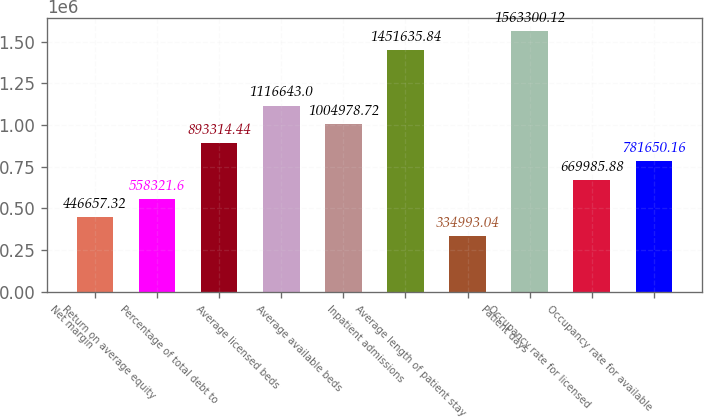Convert chart. <chart><loc_0><loc_0><loc_500><loc_500><bar_chart><fcel>Net margin<fcel>Return on average equity<fcel>Percentage of total debt to<fcel>Average licensed beds<fcel>Average available beds<fcel>Inpatient admissions<fcel>Average length of patient stay<fcel>Patient days<fcel>Occupancy rate for licensed<fcel>Occupancy rate for available<nl><fcel>446657<fcel>558322<fcel>893314<fcel>1.11664e+06<fcel>1.00498e+06<fcel>1.45164e+06<fcel>334993<fcel>1.5633e+06<fcel>669986<fcel>781650<nl></chart> 